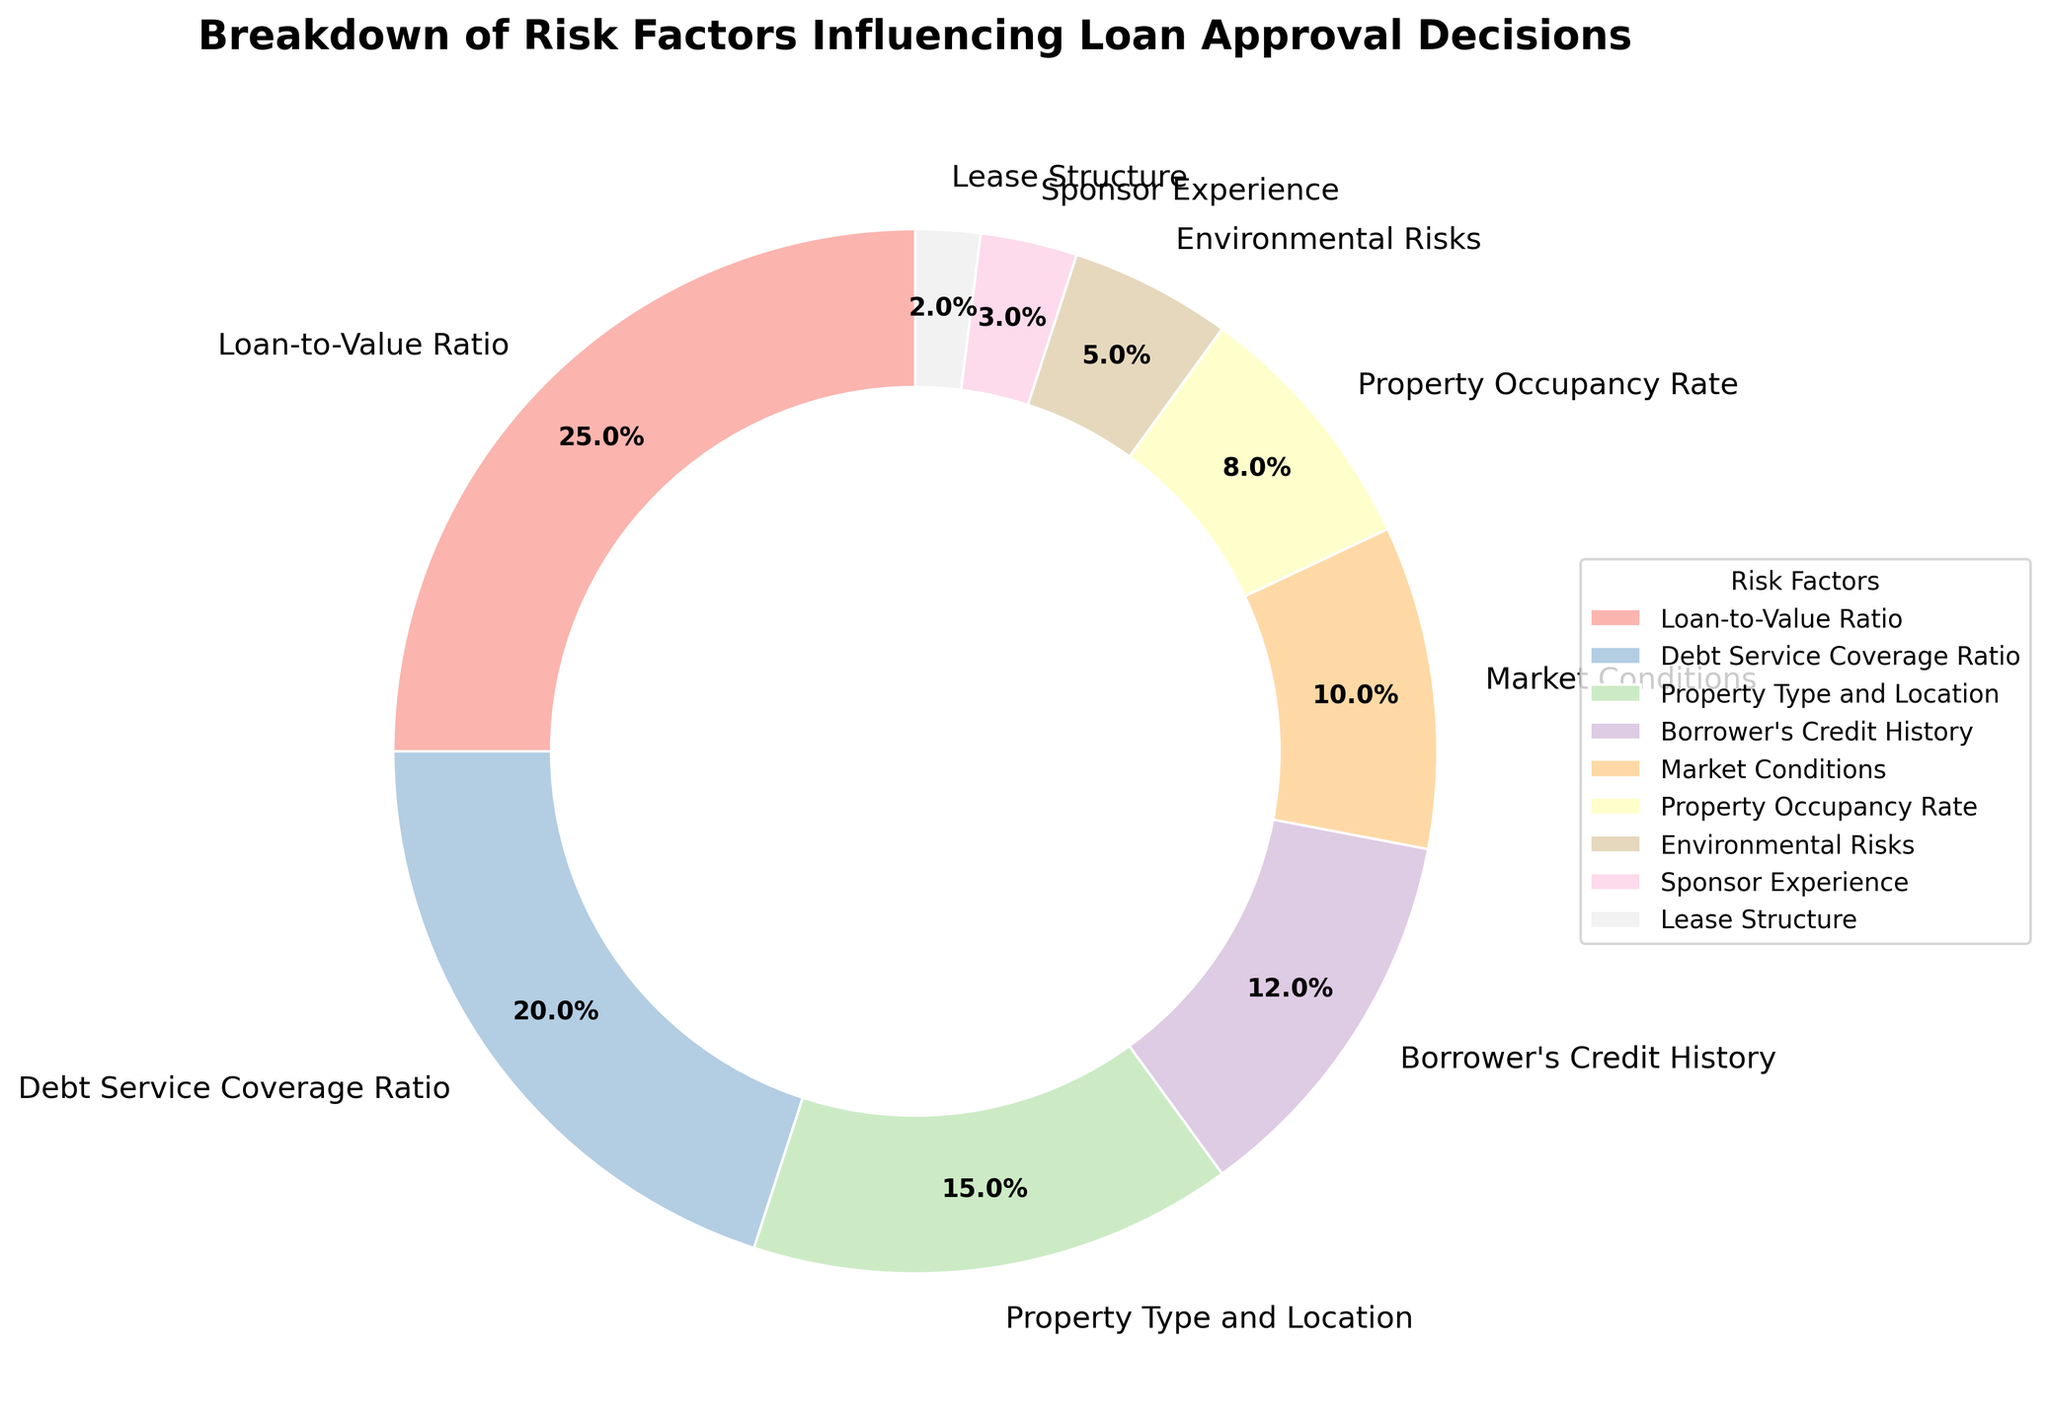What percentage of the risk factors combined does the Loan-to-Value Ratio and Debt Service Coverage Ratio represent? To find the combined percentage, add the percentages of the Loan-to-Value Ratio (25%) and the Debt Service Coverage Ratio (20%). The sum is 25% + 20% = 45%.
Answer: 45% Which risk factor contributes the least to loan approval decisions? Look at the pie chart and find the smallest segment. The segment for Lease Structure, representing 2%, is the smallest.
Answer: Lease Structure Is Borrower's Credit History more significant than Property Occupancy Rate in influencing loan approval decisions? Compare the percentages of Borrower's Credit History (12%) and Property Occupancy Rate (8%). Since 12% is greater than 8%, Borrower's Credit History is more significant.
Answer: Yes Which risk factor is represented by the largest segment in the chart? The largest segment in the pie chart represents the Loan-to-Value Ratio, which has the highest percentage at 25%.
Answer: Loan-to-Value Ratio Compare the percentages of Environmental Risks and Sponsor Experience. Which one has a higher influence on loan approval decisions? Check the percentages for Environmental Risks (5%) and Sponsor Experience (3%). Since 5% is greater than 3%, Environmental Risks have a higher influence.
Answer: Environmental Risks What is the combined percentage of Market Conditions, Property Occupancy Rate, and Environmental Risks? Add the percentages for Market Conditions (10%), Property Occupancy Rate (8%), and Environmental Risks (5%). The sum is 10% + 8% + 5% = 23%.
Answer: 23% Which risk factors contribute more than 10% each to loan approval decisions? Look for segments with percentages greater than 10%. The Loan-to-Value Ratio (25%) and Debt Service Coverage Ratio (20%) are both greater than 10%.
Answer: Loan-to-Value Ratio and Debt Service Coverage Ratio What is the difference in percentage between Property Type and Location and Sponsor Experience? Subtract the percentage of Sponsor Experience (3%) from Property Type and Location (15%). The difference is 15% - 3% = 12%.
Answer: 12% Which segment has a larger percentage: the Borrower's Credit History or Market Conditions? Compare the segments' percentages of Borrower's Credit History (12%) and Market Conditions (10%). Since 12% is greater than 10%, Borrower's Credit History has a larger percentage.
Answer: Borrower's Credit History What's the total percentage of the risk factors contributing less than 10% each? Add the percentages of risk factors contributing less than 10%: Property Occupancy Rate (8%), Environmental Risks (5%), Sponsor Experience (3%), and Lease Structure (2%). The sum is 8% + 5% + 3% + 2% = 18%.
Answer: 18% 